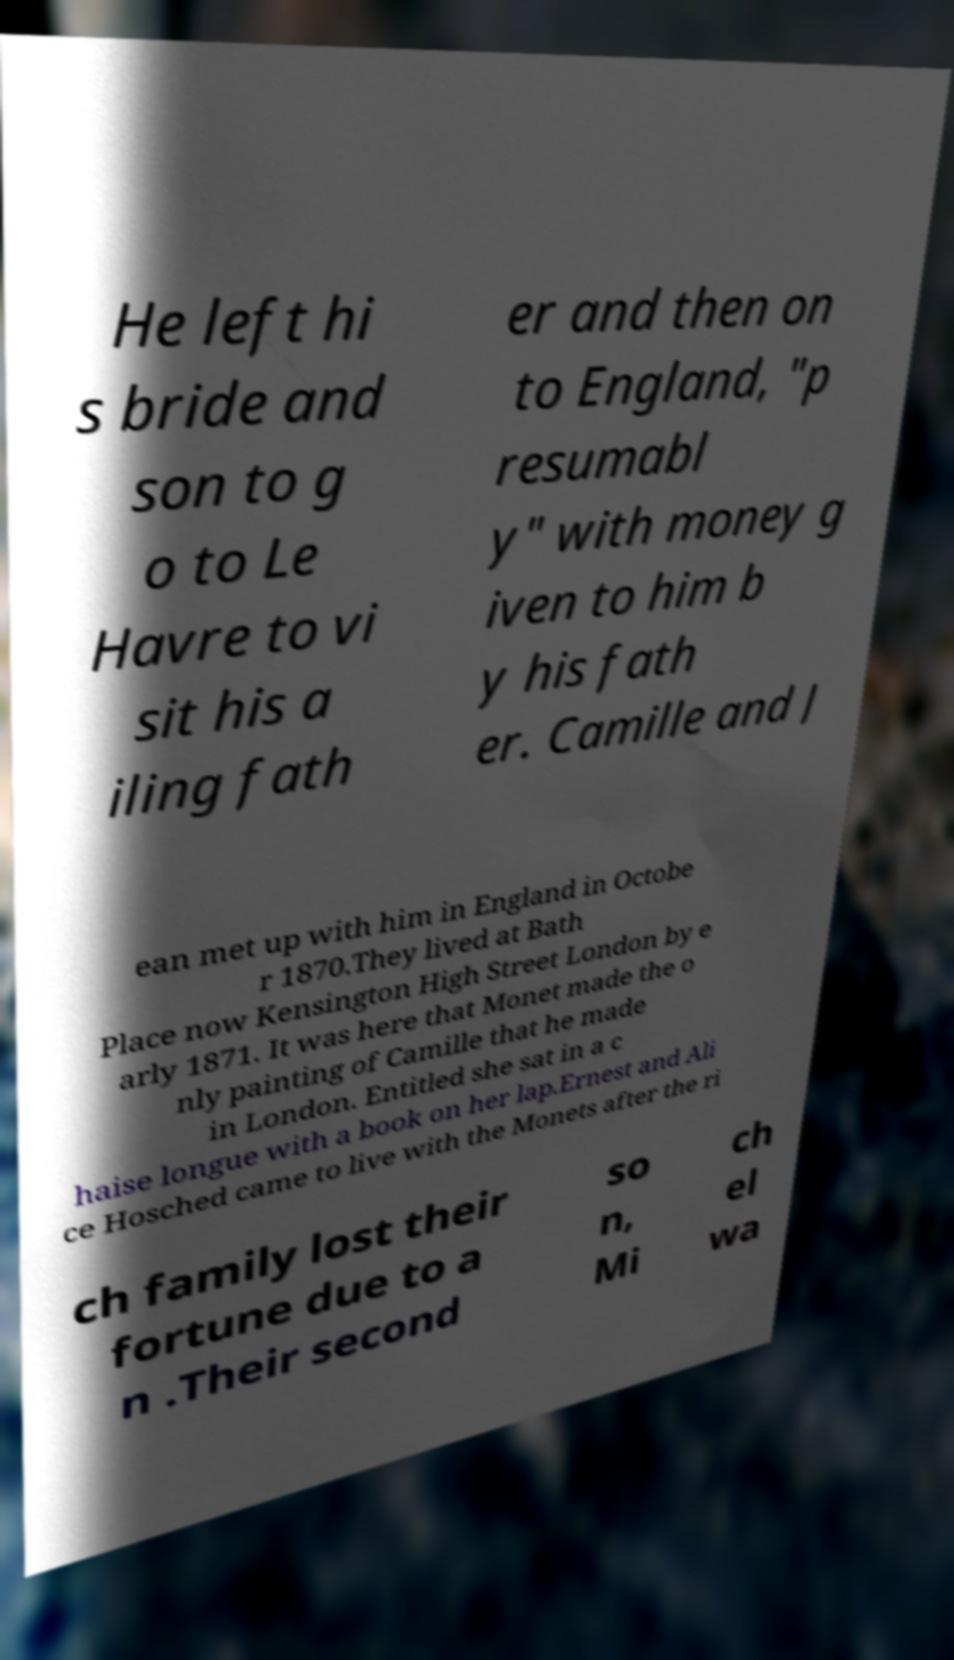I need the written content from this picture converted into text. Can you do that? He left hi s bride and son to g o to Le Havre to vi sit his a iling fath er and then on to England, "p resumabl y" with money g iven to him b y his fath er. Camille and J ean met up with him in England in Octobe r 1870.They lived at Bath Place now Kensington High Street London by e arly 1871. It was here that Monet made the o nly painting of Camille that he made in London. Entitled she sat in a c haise longue with a book on her lap.Ernest and Ali ce Hosched came to live with the Monets after the ri ch family lost their fortune due to a n .Their second so n, Mi ch el wa 